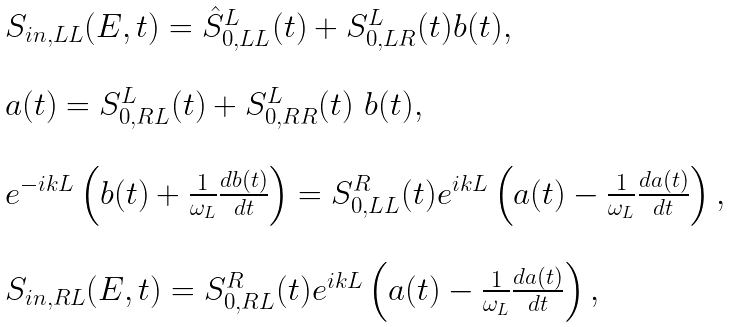Convert formula to latex. <formula><loc_0><loc_0><loc_500><loc_500>\begin{array} { l } S _ { i n , L L } ( E , t ) = \hat { S } ^ { L } _ { 0 , L L } ( t ) + S ^ { L } _ { 0 , L R } ( t ) b ( t ) , \\ \ \\ a ( t ) = S ^ { L } _ { 0 , R L } ( t ) + S ^ { L } _ { 0 , R R } ( t ) \ b ( t ) , \\ \ \\ e ^ { - i k L } \left ( b ( t ) + \frac { 1 } { \omega _ { L } } \frac { d b ( t ) } { d t } \right ) = S ^ { R } _ { 0 , L L } ( t ) e ^ { i k L } \left ( a ( t ) - \frac { 1 } { \omega _ { L } } \frac { d a ( t ) } { d t } \right ) , \\ \ \\ S _ { i n , R L } ( E , t ) = S ^ { R } _ { 0 , R L } ( t ) e ^ { i k L } \left ( a ( t ) - \frac { 1 } { \omega _ { L } } \frac { d a ( t ) } { d t } \right ) , \end{array}</formula> 